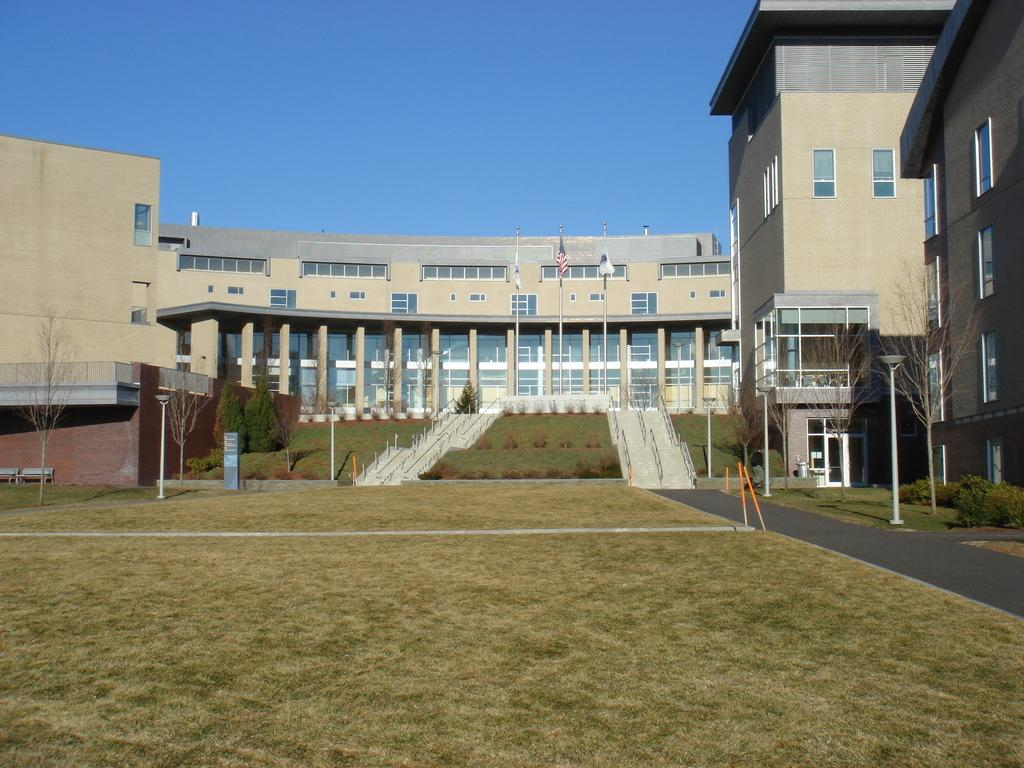What type of vegetation is present on the ground in the image? There is grass on the ground in the image. What architectural feature can be seen in the image? There are steps in the image. What type of structures are visible in the image? There are buildings visible in the image. What color is the sky at the top of the image? The sky is blue at the top of the image. Can you see a rat digging with a spade in the grass in the image? There is no rat or spade present in the image; it features grass, steps, buildings, and a blue sky. 